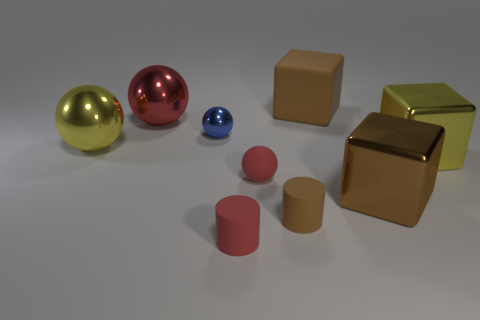Subtract all cubes. How many objects are left? 6 Subtract all small red cylinders. Subtract all spheres. How many objects are left? 4 Add 2 balls. How many balls are left? 6 Add 7 small red objects. How many small red objects exist? 9 Subtract 0 red blocks. How many objects are left? 9 